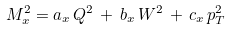Convert formula to latex. <formula><loc_0><loc_0><loc_500><loc_500>M _ { x } ^ { 2 } = a _ { x } \, Q ^ { 2 } \, + \, b _ { x } \, W ^ { 2 } \, + \, c _ { x } \, p _ { T } ^ { 2 }</formula> 